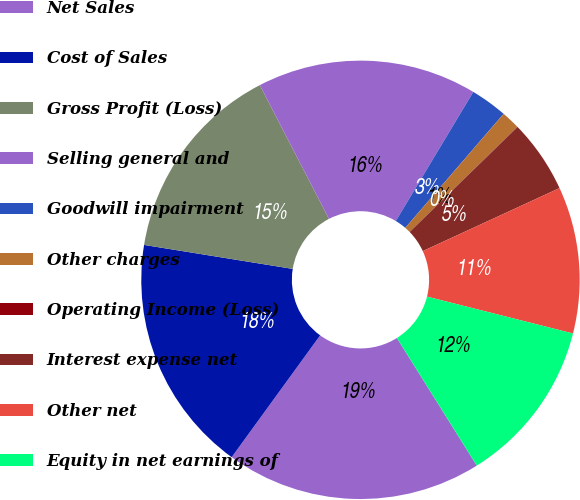Convert chart. <chart><loc_0><loc_0><loc_500><loc_500><pie_chart><fcel>Net Sales<fcel>Cost of Sales<fcel>Gross Profit (Loss)<fcel>Selling general and<fcel>Goodwill impairment<fcel>Other charges<fcel>Operating Income (Loss)<fcel>Interest expense net<fcel>Other net<fcel>Equity in net earnings of<nl><fcel>18.9%<fcel>17.55%<fcel>14.86%<fcel>16.2%<fcel>2.72%<fcel>1.37%<fcel>0.02%<fcel>5.41%<fcel>10.81%<fcel>12.16%<nl></chart> 